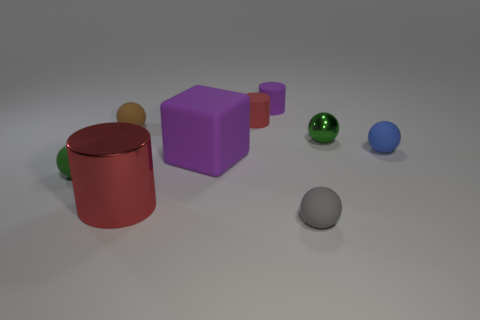There is a red thing that is made of the same material as the tiny brown object; what size is it?
Make the answer very short. Small. What number of other things are the same shape as the gray object?
Ensure brevity in your answer.  4. There is a tiny sphere that is both behind the small blue ball and to the right of the big red metallic thing; what material is it made of?
Provide a succinct answer. Metal. What is the size of the green matte sphere?
Provide a succinct answer. Small. There is a tiny blue sphere that is behind the green sphere on the left side of the brown sphere; what number of small purple matte objects are in front of it?
Provide a succinct answer. 0. What shape is the metallic object that is right of the metallic thing that is to the left of the tiny metal object?
Provide a short and direct response. Sphere. There is a gray matte object that is the same shape as the blue matte thing; what is its size?
Ensure brevity in your answer.  Small. The metallic thing on the right side of the red shiny object is what color?
Provide a succinct answer. Green. The green sphere behind the green sphere that is in front of the big purple cube that is in front of the tiny purple rubber object is made of what material?
Keep it short and to the point. Metal. What is the size of the cylinder in front of the small thing to the left of the small brown rubber sphere?
Your answer should be very brief. Large. 